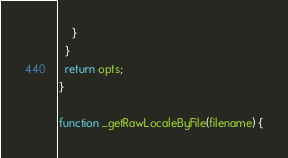<code> <loc_0><loc_0><loc_500><loc_500><_JavaScript_>    }
  }
  return opts;
}

function _getRawLocaleByFile(filename) {</code> 